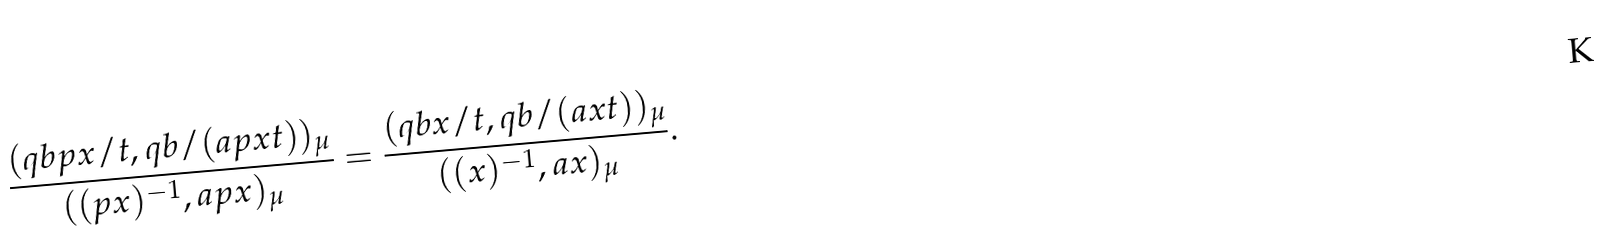Convert formula to latex. <formula><loc_0><loc_0><loc_500><loc_500>\frac { ( q b p x / t , q b / ( a p x t ) ) _ { \mu } } { ( ( p x ) ^ { - 1 } , a p x ) _ { \mu } } = \frac { ( q b x / t , q b / ( a x t ) ) _ { \mu } } { ( ( x ) ^ { - 1 } , a x ) _ { \mu } } .</formula> 